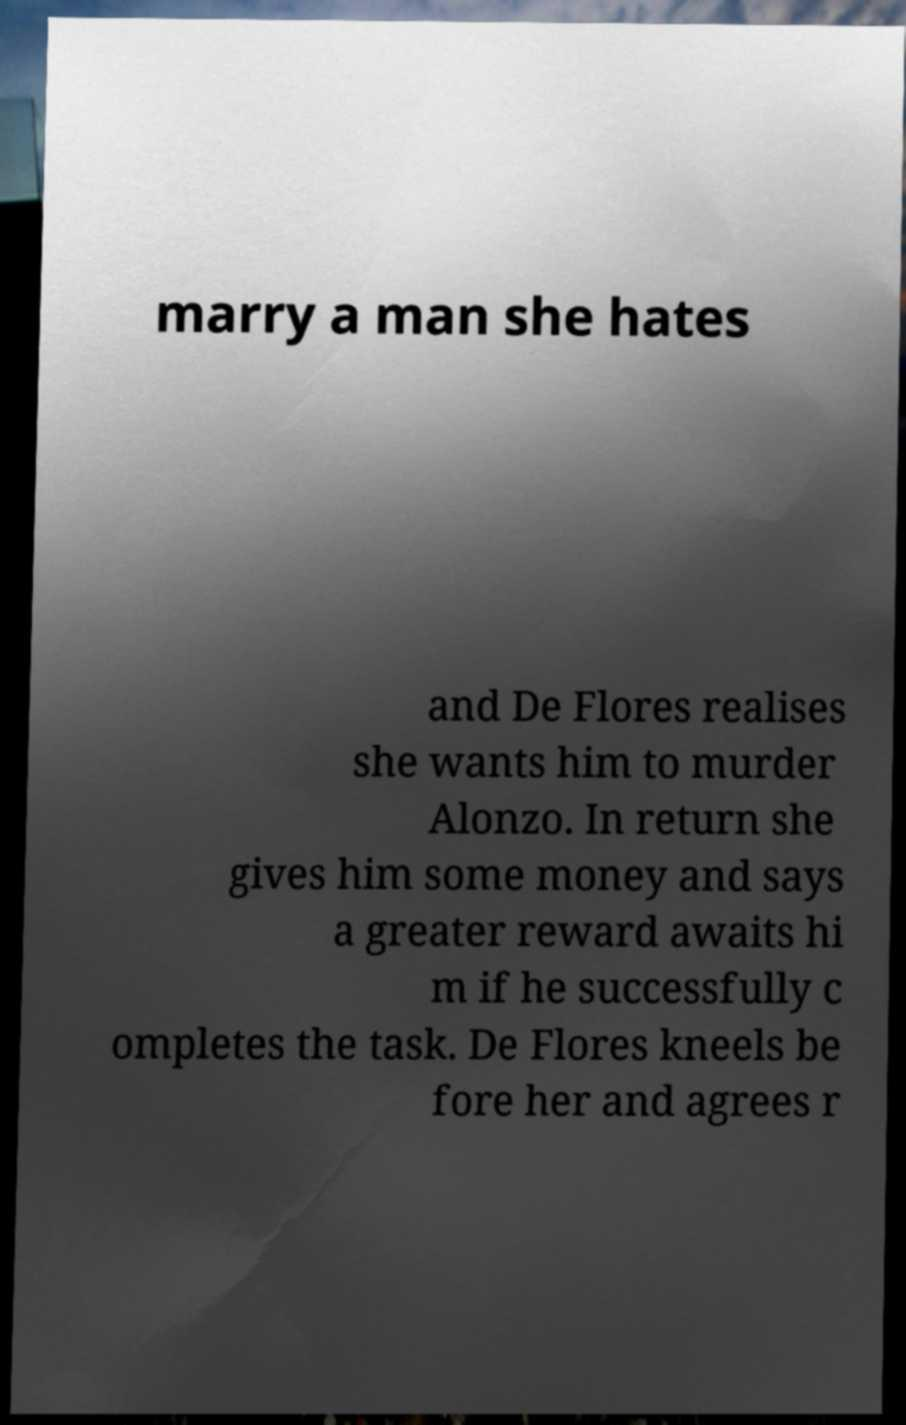For documentation purposes, I need the text within this image transcribed. Could you provide that? marry a man she hates and De Flores realises she wants him to murder Alonzo. In return she gives him some money and says a greater reward awaits hi m if he successfully c ompletes the task. De Flores kneels be fore her and agrees r 